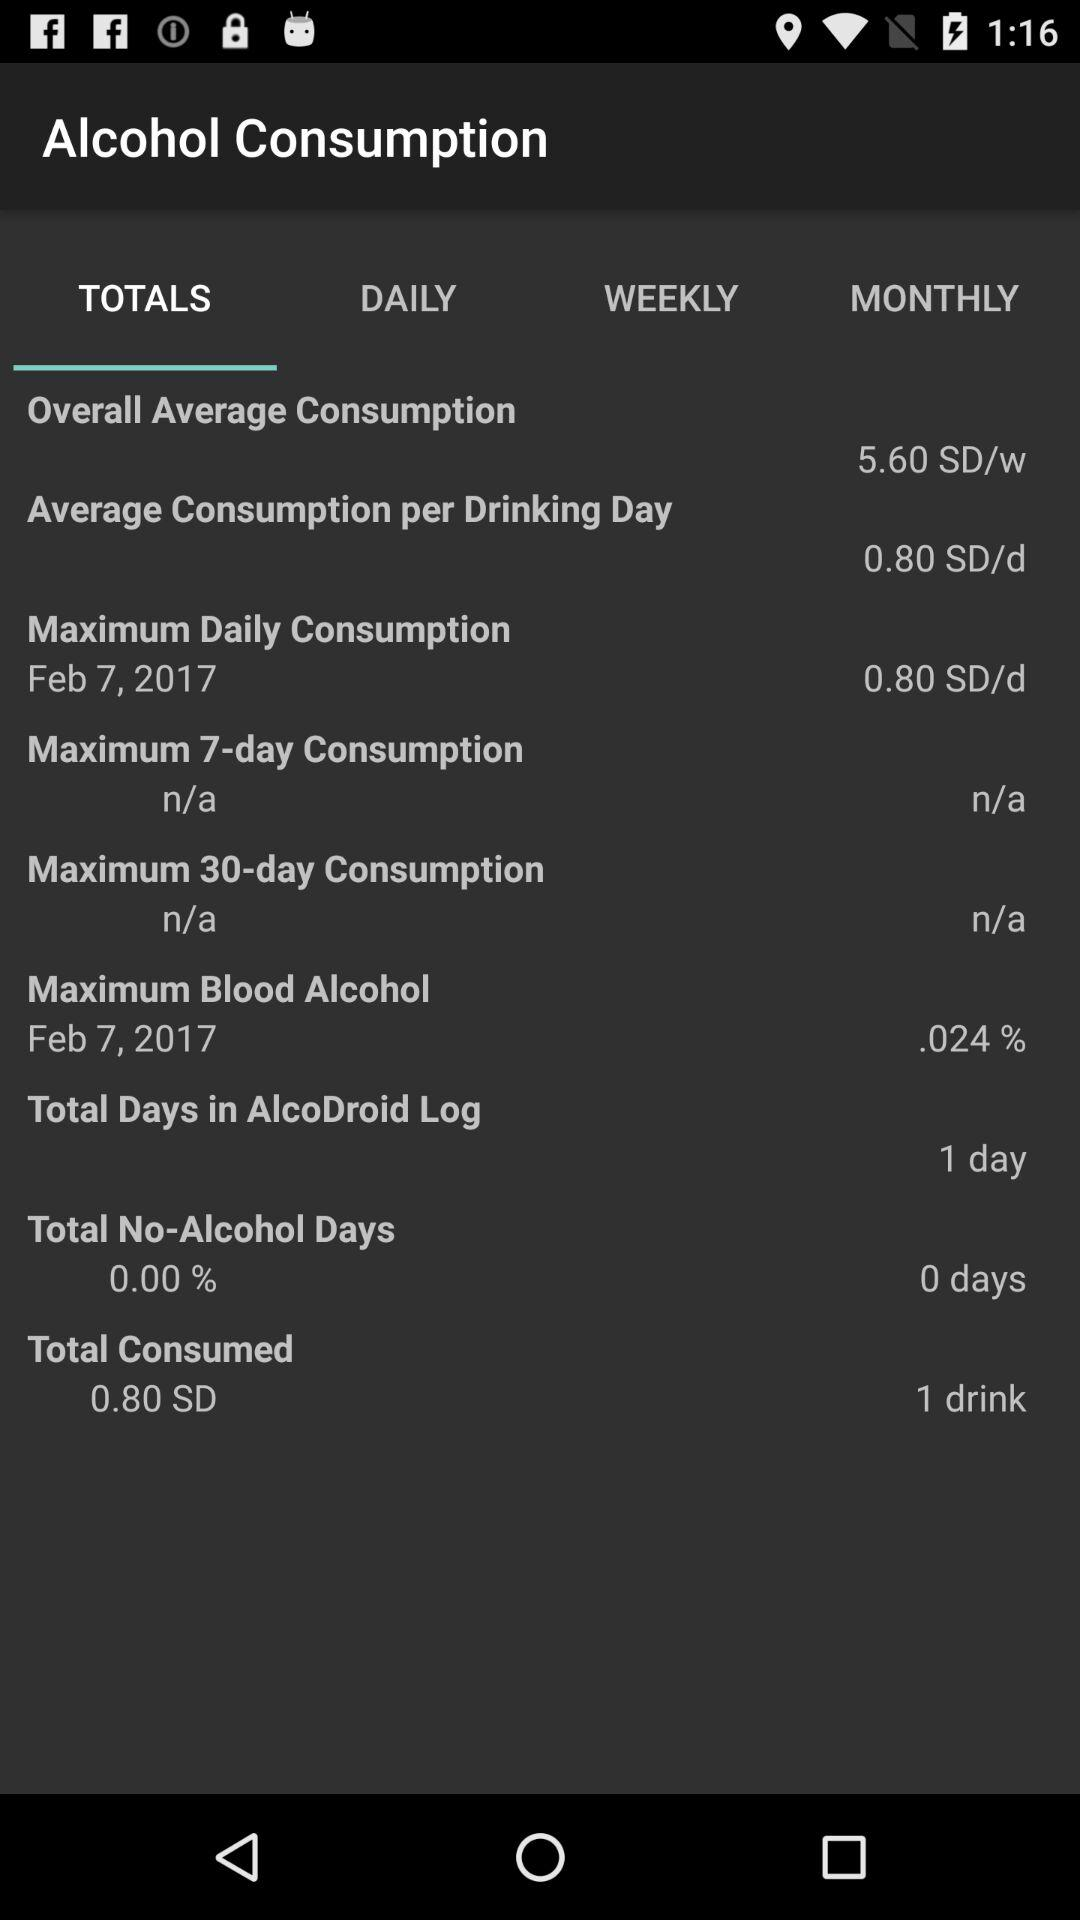What is the total number of drinks consumed?
Answer the question using a single word or phrase. 1 drink 